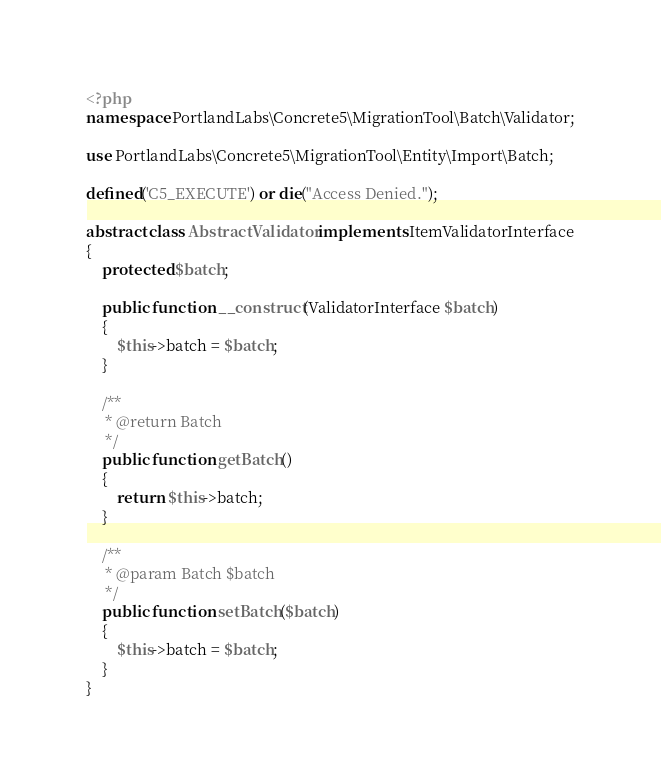Convert code to text. <code><loc_0><loc_0><loc_500><loc_500><_PHP_><?php
namespace PortlandLabs\Concrete5\MigrationTool\Batch\Validator;

use PortlandLabs\Concrete5\MigrationTool\Entity\Import\Batch;

defined('C5_EXECUTE') or die("Access Denied.");

abstract class AbstractValidator implements ItemValidatorInterface
{
    protected $batch;

    public function __construct(ValidatorInterface $batch)
    {
        $this->batch = $batch;
    }

    /**
     * @return Batch
     */
    public function getBatch()
    {
        return $this->batch;
    }

    /**
     * @param Batch $batch
     */
    public function setBatch($batch)
    {
        $this->batch = $batch;
    }
}
</code> 